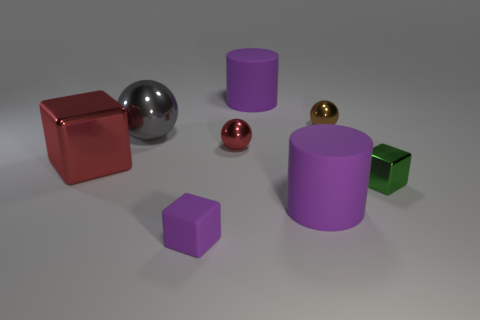Add 1 small green metallic blocks. How many objects exist? 9 Subtract all blocks. How many objects are left? 5 Add 2 balls. How many balls are left? 5 Add 6 big cubes. How many big cubes exist? 7 Subtract 0 gray cubes. How many objects are left? 8 Subtract all small balls. Subtract all small blue things. How many objects are left? 6 